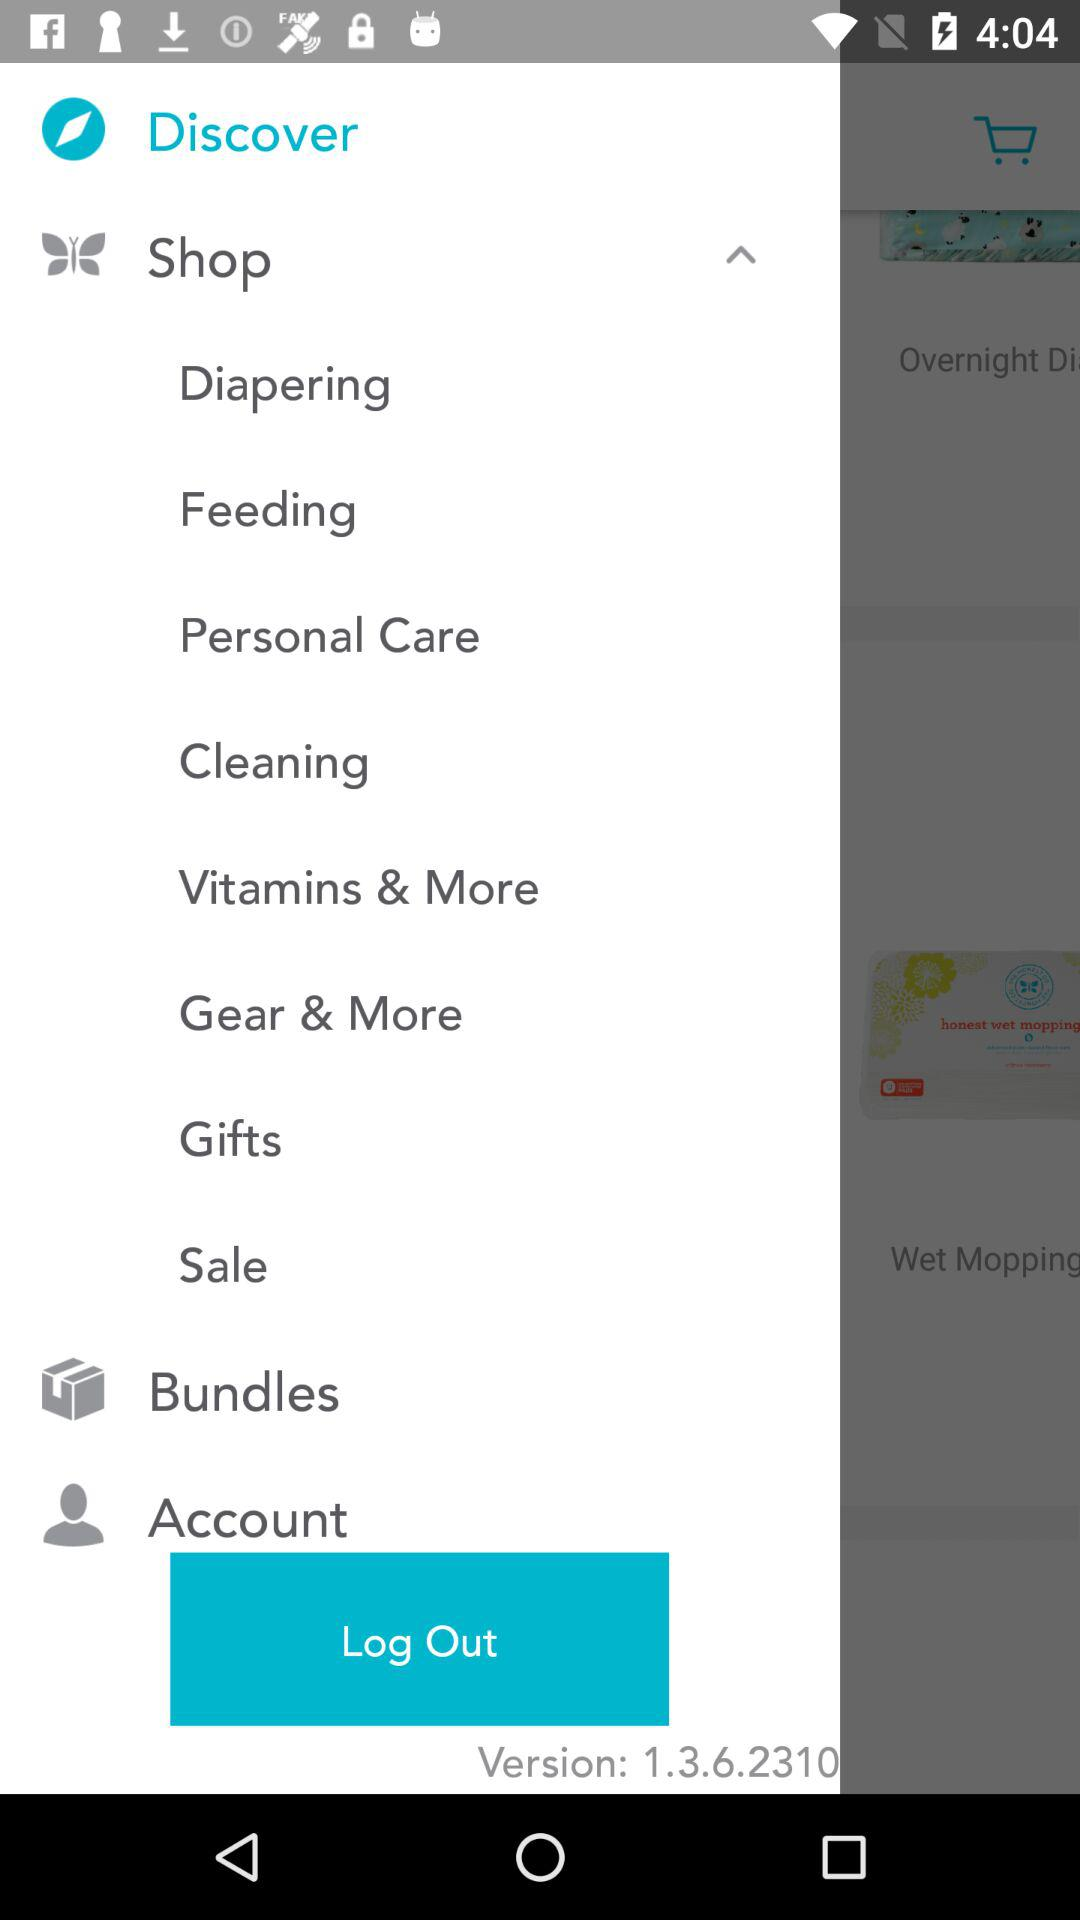What is the version of the application? The version of the application is 1.3.6.2310. 